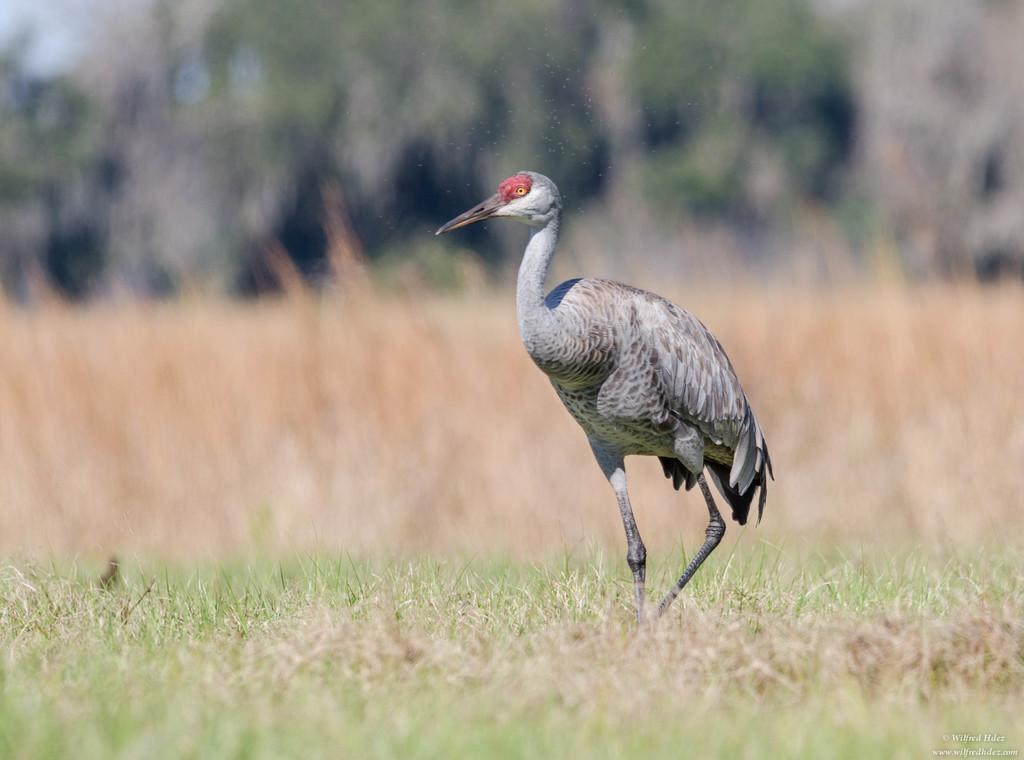What type of animal can be seen in the image? There is a bird in the image. Where is the bird located? The bird is on the grass. What can be seen in the background of the image? There are trees in the background of the image. What type of fuel does the bird use to fly in the image? Birds do not use fuel to fly; they use their wings and muscles to generate lift and propel themselves through the air. 